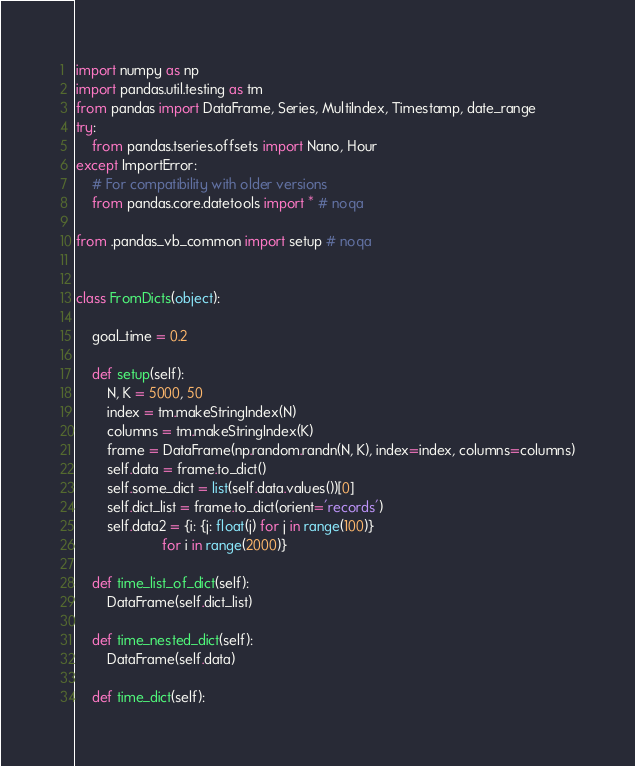<code> <loc_0><loc_0><loc_500><loc_500><_Python_>import numpy as np
import pandas.util.testing as tm
from pandas import DataFrame, Series, MultiIndex, Timestamp, date_range
try:
    from pandas.tseries.offsets import Nano, Hour
except ImportError:
    # For compatibility with older versions
    from pandas.core.datetools import * # noqa

from .pandas_vb_common import setup # noqa


class FromDicts(object):

    goal_time = 0.2

    def setup(self):
        N, K = 5000, 50
        index = tm.makeStringIndex(N)
        columns = tm.makeStringIndex(K)
        frame = DataFrame(np.random.randn(N, K), index=index, columns=columns)
        self.data = frame.to_dict()
        self.some_dict = list(self.data.values())[0]
        self.dict_list = frame.to_dict(orient='records')
        self.data2 = {i: {j: float(j) for j in range(100)}
                      for i in range(2000)}

    def time_list_of_dict(self):
        DataFrame(self.dict_list)

    def time_nested_dict(self):
        DataFrame(self.data)

    def time_dict(self):</code> 